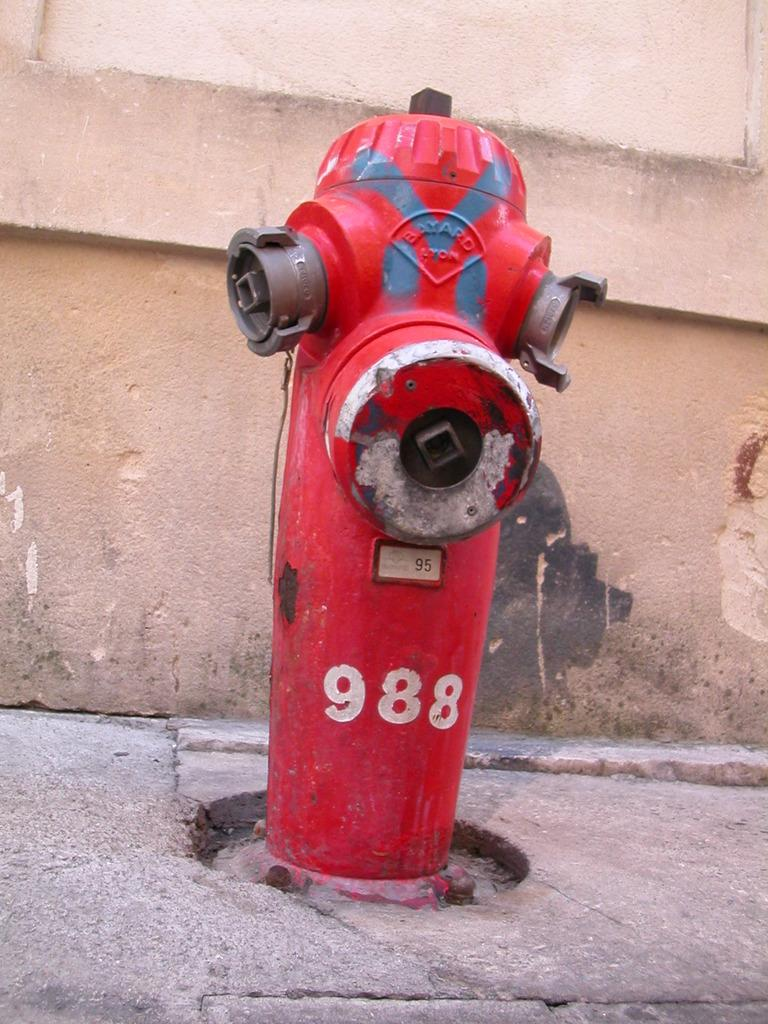What is the color of the fire hydrant in the image? The fire hydrant in the image is red. Is there any text or number on the fire hydrant? Yes, the number "988" is written on the fire hydrant. What can be seen in the background of the image? There is a wall visible in the background of the image. How does the grandfather contribute to the attraction in the image? There is no grandfather present in the image, so it is not possible to determine how he might contribute to any attraction. 